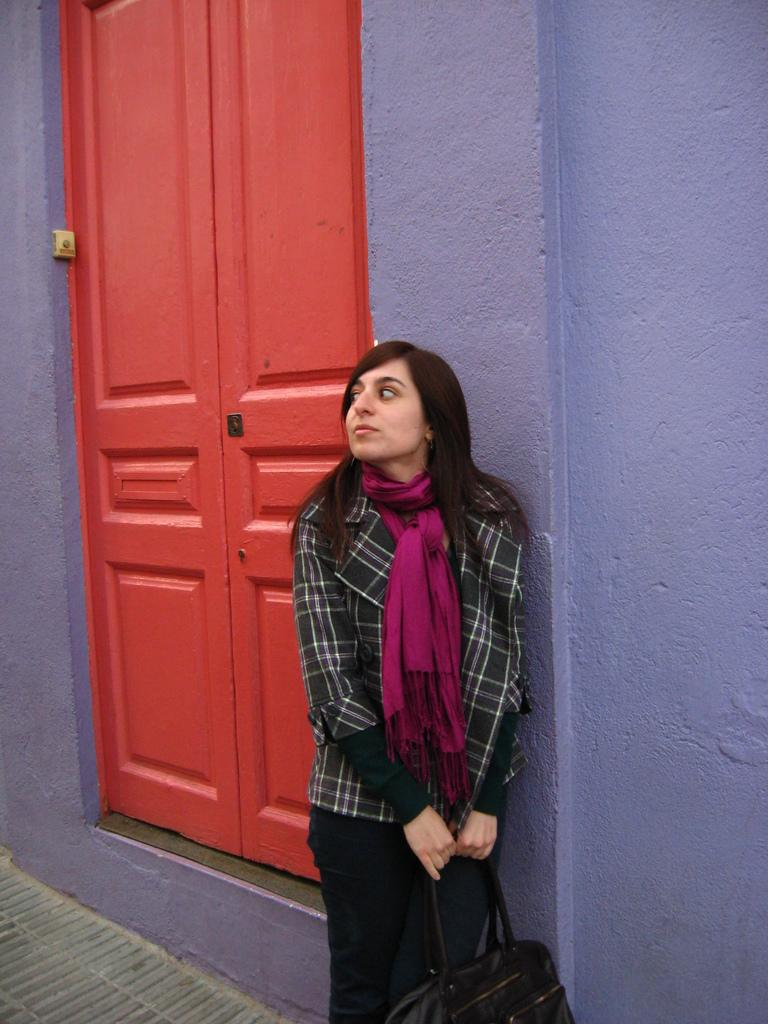Who is present in the image? There is a woman in the image. What is the woman doing in the image? The woman is standing at a wall. What is the woman holding in her hands? The woman is holding a bag in her hands. What can be seen in the background of the image? There are doors in the background of the image. What is on the wall near the door in the background? There is an object on the wall at the door in the background. What discovery did the woman make while standing at the wall in the image? There is no indication in the image that the woman made any discovery while standing at the wall. 